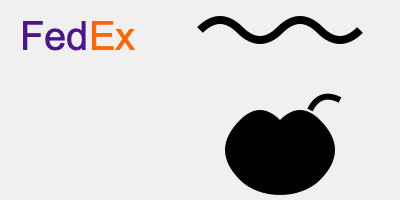Which of the logos shown above most effectively utilizes negative space to create a hidden element, enhancing brand recognition and memorability? To answer this question, we need to analyze each logo for its use of negative space:

1. FedEx Logo:
   - Look closely at the space between the letters 'E' and 'x'.
   - There's a hidden arrow formed by the negative space, pointing to the right.
   - This arrow symbolizes forward movement, speed, and precision.

2. WWF (World Wildlife Fund) Logo:
   - The black curves form the silhouette of a panda.
   - While effective, it doesn't utilize negative space to create a hidden element.

3. Apple Logo:
   - The bite taken out of the apple is a clever use of negative space.
   - However, it doesn't create a separate, hidden element within the logo.

The FedEx logo stands out for its ingenious use of negative space. The hidden arrow is subtle yet impactful, adding an extra layer of meaning to the brand's identity. It's often cited as one of the best examples of negative space in logo design.

This use of negative space:
- Increases brand recognition
- Makes the logo more memorable
- Adds depth and meaning to the design
- Demonstrates clever, thoughtful branding

Therefore, among the given options, the FedEx logo most effectively utilizes negative space to create a hidden element that enhances brand recognition and memorability.
Answer: FedEx logo 